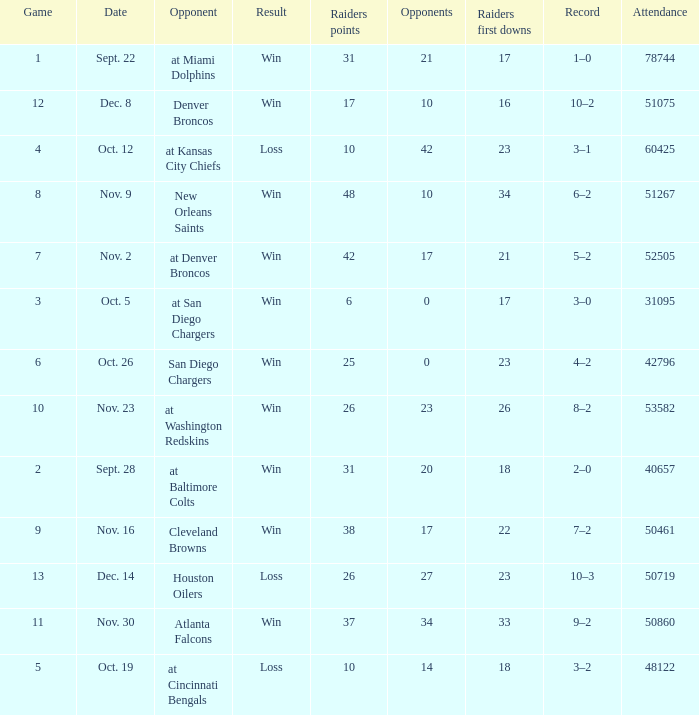Who was the game attended by 60425 people played against? At kansas city chiefs. 